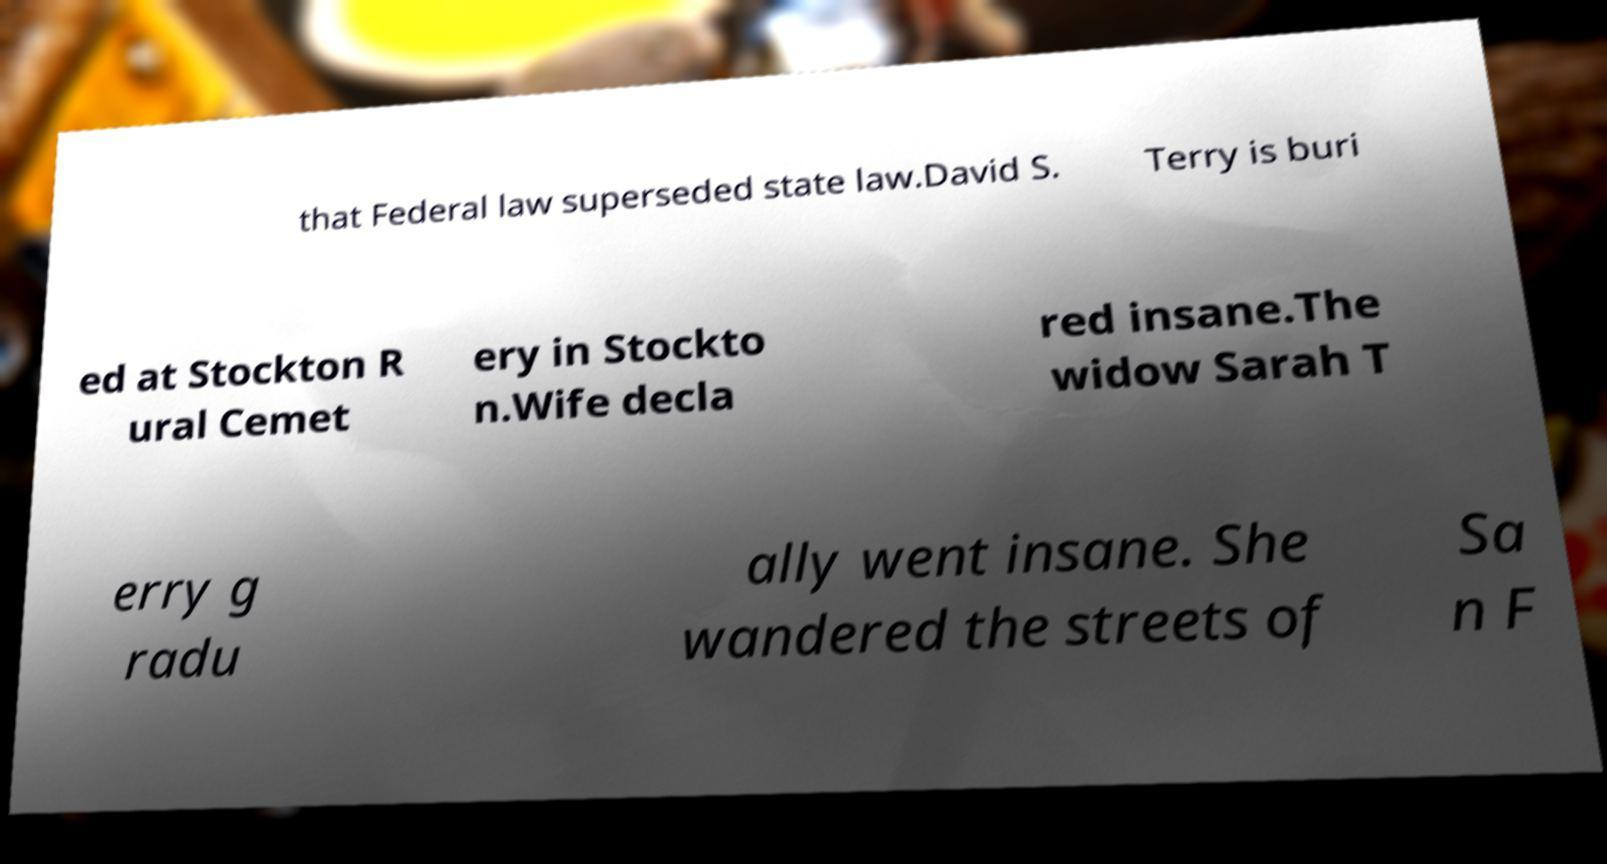Could you assist in decoding the text presented in this image and type it out clearly? that Federal law superseded state law.David S. Terry is buri ed at Stockton R ural Cemet ery in Stockto n.Wife decla red insane.The widow Sarah T erry g radu ally went insane. She wandered the streets of Sa n F 